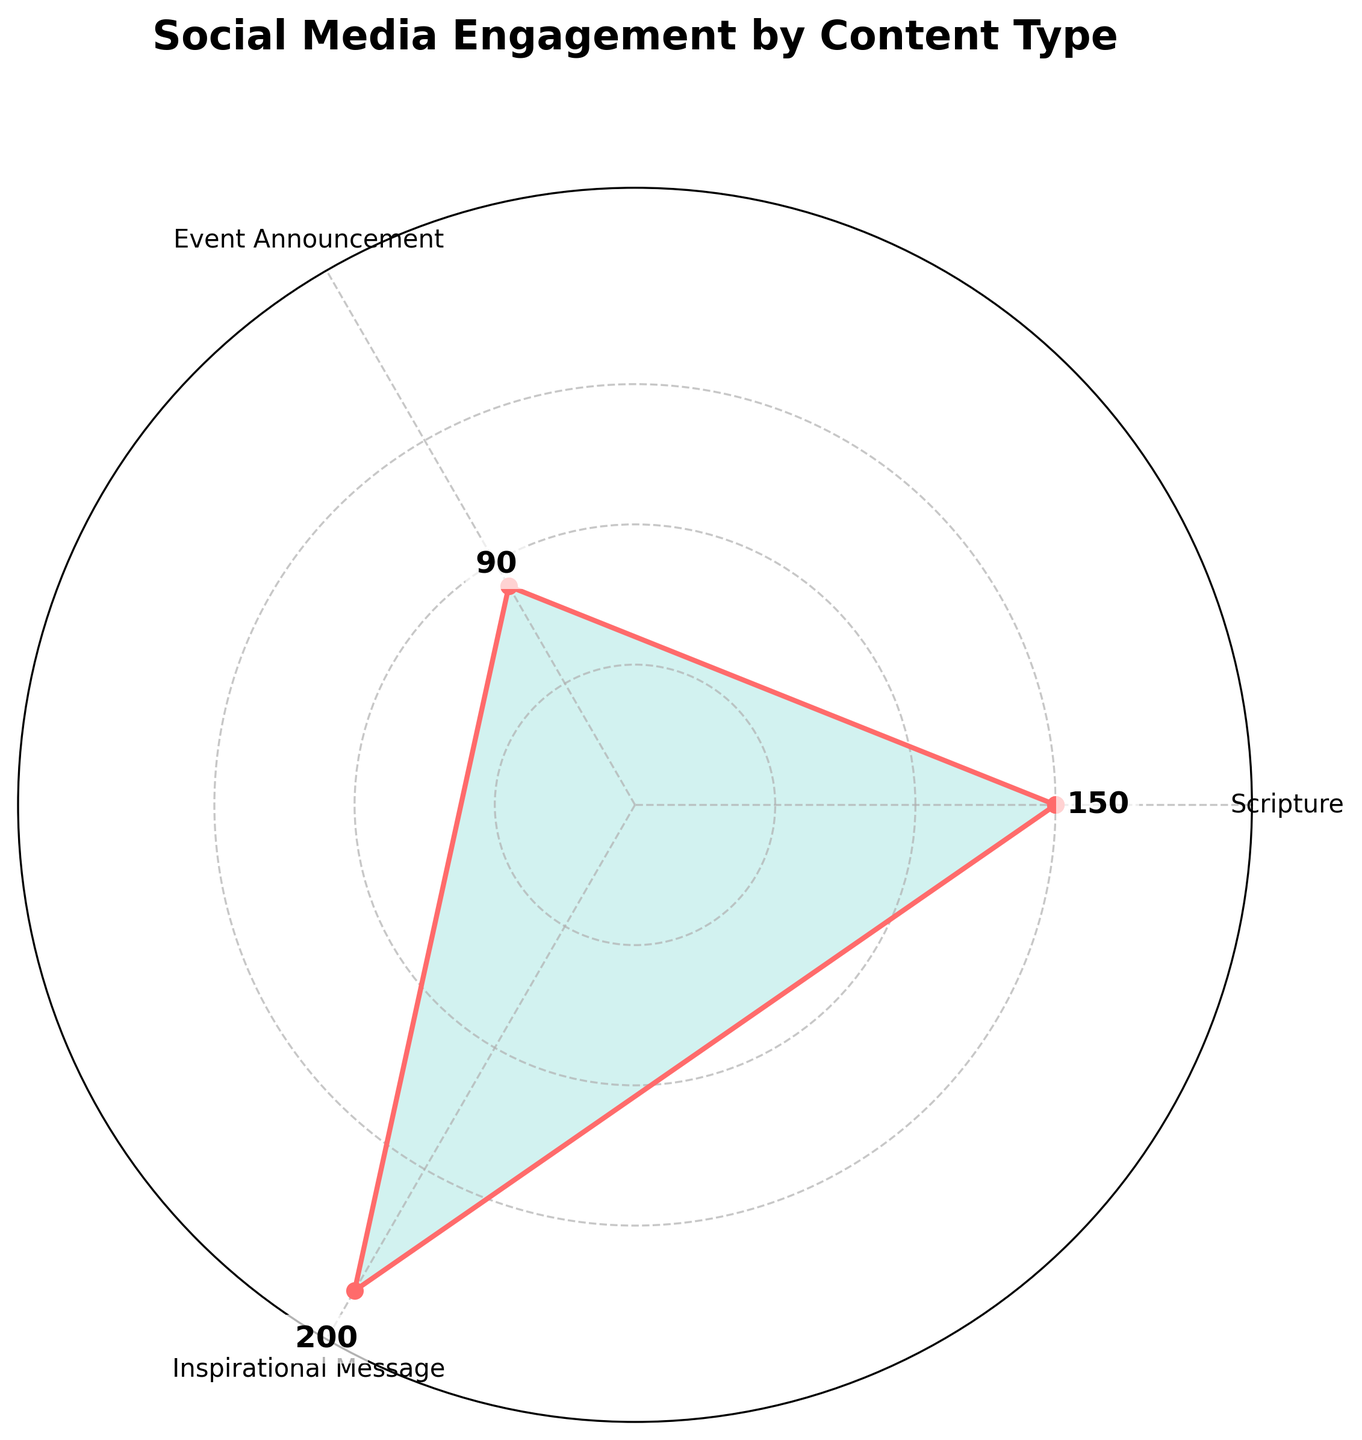What is the title of the chart? The title is displayed at the top of the chart.
Answer: Social Media Engagement by Content Type How many types of content are displayed in the chart? The chart shows three different types of content.
Answer: 3 What color is used to fill the area under the lines? The filled area under the lines is colored.
Answer: Light Teal What is the total engagement across all types of content? Sum the engagement values for all content types: 150 + 90 + 200.
Answer: 440 What is the average engagement per content type? Sum the engagement values for all content types and divide by the number of content types: (150 + 90 + 200) / 3.
Answer: 146.67 Which type of content has the highest engagement? Among the engagement values, the highest value is 200 for Inspirational Message.
Answer: Inspirational Message Which type of content has the lowest engagement? Among the engagement values, the lowest value is 90 for Event Announcement.
Answer: Event Announcement How much more engagement does Inspirational Message have compared to Event Announcement? Subtract the engagement of Event Announcement from Inspirational Message: 200 - 90.
Answer: 110 What is the engagement value for Scripture posts as shown in the chart? The value labeled for Scripture posts is 150 in the chart.
Answer: 150 Are all segments in the chart equally spaced? The radial plot divides the circle uniformly for each content type.
Answer: Yes 